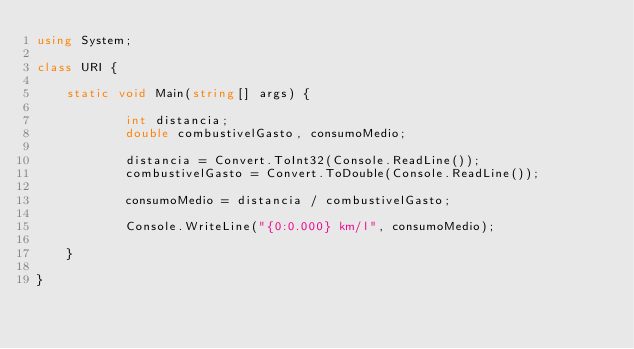Convert code to text. <code><loc_0><loc_0><loc_500><loc_500><_C#_>using System; 

class URI {

    static void Main(string[] args) { 

            int distancia;
            double combustivelGasto, consumoMedio;

            distancia = Convert.ToInt32(Console.ReadLine());
            combustivelGasto = Convert.ToDouble(Console.ReadLine());

            consumoMedio = distancia / combustivelGasto;

            Console.WriteLine("{0:0.000} km/l", consumoMedio);

    }

}</code> 